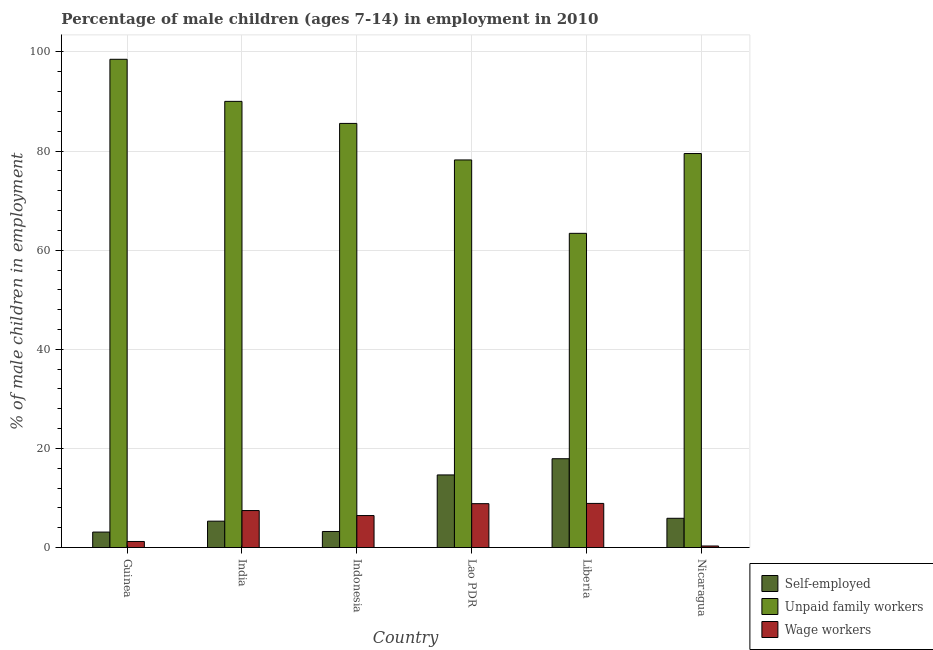How many different coloured bars are there?
Ensure brevity in your answer.  3. How many groups of bars are there?
Provide a short and direct response. 6. Are the number of bars per tick equal to the number of legend labels?
Keep it short and to the point. Yes. Are the number of bars on each tick of the X-axis equal?
Keep it short and to the point. Yes. What is the label of the 1st group of bars from the left?
Provide a short and direct response. Guinea. In how many cases, is the number of bars for a given country not equal to the number of legend labels?
Keep it short and to the point. 0. What is the percentage of self employed children in Liberia?
Provide a short and direct response. 17.92. Across all countries, what is the minimum percentage of children employed as wage workers?
Give a very brief answer. 0.31. In which country was the percentage of self employed children maximum?
Provide a short and direct response. Liberia. In which country was the percentage of children employed as unpaid family workers minimum?
Offer a terse response. Liberia. What is the total percentage of children employed as unpaid family workers in the graph?
Your answer should be very brief. 495.24. What is the difference between the percentage of self employed children in India and that in Liberia?
Provide a succinct answer. -12.6. What is the difference between the percentage of children employed as unpaid family workers in Nicaragua and the percentage of children employed as wage workers in Guinea?
Your answer should be compact. 78.28. What is the average percentage of self employed children per country?
Your answer should be compact. 8.36. What is the difference between the percentage of children employed as unpaid family workers and percentage of self employed children in Guinea?
Provide a succinct answer. 95.4. In how many countries, is the percentage of self employed children greater than 76 %?
Give a very brief answer. 0. What is the ratio of the percentage of self employed children in Guinea to that in Indonesia?
Give a very brief answer. 0.96. Is the percentage of self employed children in Lao PDR less than that in Nicaragua?
Offer a very short reply. No. What is the difference between the highest and the second highest percentage of children employed as wage workers?
Give a very brief answer. 0.05. What is the difference between the highest and the lowest percentage of children employed as unpaid family workers?
Your response must be concise. 35.12. In how many countries, is the percentage of children employed as unpaid family workers greater than the average percentage of children employed as unpaid family workers taken over all countries?
Your answer should be very brief. 3. What does the 3rd bar from the left in Nicaragua represents?
Your answer should be compact. Wage workers. What does the 1st bar from the right in India represents?
Offer a terse response. Wage workers. Are all the bars in the graph horizontal?
Make the answer very short. No. Are the values on the major ticks of Y-axis written in scientific E-notation?
Provide a short and direct response. No. Does the graph contain any zero values?
Provide a succinct answer. No. What is the title of the graph?
Offer a terse response. Percentage of male children (ages 7-14) in employment in 2010. Does "Infant(male)" appear as one of the legend labels in the graph?
Ensure brevity in your answer.  No. What is the label or title of the X-axis?
Offer a very short reply. Country. What is the label or title of the Y-axis?
Make the answer very short. % of male children in employment. What is the % of male children in employment of Self-employed in Guinea?
Provide a succinct answer. 3.12. What is the % of male children in employment in Unpaid family workers in Guinea?
Your response must be concise. 98.52. What is the % of male children in employment of Wage workers in Guinea?
Provide a short and direct response. 1.22. What is the % of male children in employment in Self-employed in India?
Give a very brief answer. 5.32. What is the % of male children in employment of Unpaid family workers in India?
Offer a very short reply. 90.03. What is the % of male children in employment in Wage workers in India?
Provide a short and direct response. 7.46. What is the % of male children in employment of Self-employed in Indonesia?
Your answer should be very brief. 3.24. What is the % of male children in employment of Unpaid family workers in Indonesia?
Ensure brevity in your answer.  85.58. What is the % of male children in employment in Wage workers in Indonesia?
Your answer should be very brief. 6.45. What is the % of male children in employment in Self-employed in Lao PDR?
Ensure brevity in your answer.  14.65. What is the % of male children in employment of Unpaid family workers in Lao PDR?
Ensure brevity in your answer.  78.21. What is the % of male children in employment of Wage workers in Lao PDR?
Ensure brevity in your answer.  8.85. What is the % of male children in employment of Self-employed in Liberia?
Give a very brief answer. 17.92. What is the % of male children in employment of Unpaid family workers in Liberia?
Provide a succinct answer. 63.4. What is the % of male children in employment in Unpaid family workers in Nicaragua?
Your answer should be very brief. 79.5. What is the % of male children in employment of Wage workers in Nicaragua?
Your answer should be compact. 0.31. Across all countries, what is the maximum % of male children in employment of Self-employed?
Your answer should be compact. 17.92. Across all countries, what is the maximum % of male children in employment of Unpaid family workers?
Your answer should be compact. 98.52. Across all countries, what is the minimum % of male children in employment of Self-employed?
Provide a short and direct response. 3.12. Across all countries, what is the minimum % of male children in employment of Unpaid family workers?
Ensure brevity in your answer.  63.4. Across all countries, what is the minimum % of male children in employment in Wage workers?
Offer a terse response. 0.31. What is the total % of male children in employment of Self-employed in the graph?
Ensure brevity in your answer.  50.15. What is the total % of male children in employment of Unpaid family workers in the graph?
Keep it short and to the point. 495.24. What is the total % of male children in employment in Wage workers in the graph?
Give a very brief answer. 33.19. What is the difference between the % of male children in employment of Self-employed in Guinea and that in India?
Your response must be concise. -2.2. What is the difference between the % of male children in employment in Unpaid family workers in Guinea and that in India?
Provide a short and direct response. 8.49. What is the difference between the % of male children in employment of Wage workers in Guinea and that in India?
Ensure brevity in your answer.  -6.24. What is the difference between the % of male children in employment in Self-employed in Guinea and that in Indonesia?
Give a very brief answer. -0.12. What is the difference between the % of male children in employment of Unpaid family workers in Guinea and that in Indonesia?
Keep it short and to the point. 12.94. What is the difference between the % of male children in employment in Wage workers in Guinea and that in Indonesia?
Offer a very short reply. -5.23. What is the difference between the % of male children in employment in Self-employed in Guinea and that in Lao PDR?
Give a very brief answer. -11.53. What is the difference between the % of male children in employment in Unpaid family workers in Guinea and that in Lao PDR?
Make the answer very short. 20.31. What is the difference between the % of male children in employment of Wage workers in Guinea and that in Lao PDR?
Your answer should be very brief. -7.63. What is the difference between the % of male children in employment of Self-employed in Guinea and that in Liberia?
Provide a short and direct response. -14.8. What is the difference between the % of male children in employment of Unpaid family workers in Guinea and that in Liberia?
Make the answer very short. 35.12. What is the difference between the % of male children in employment in Wage workers in Guinea and that in Liberia?
Your answer should be compact. -7.68. What is the difference between the % of male children in employment of Self-employed in Guinea and that in Nicaragua?
Your answer should be very brief. -2.78. What is the difference between the % of male children in employment of Unpaid family workers in Guinea and that in Nicaragua?
Provide a short and direct response. 19.02. What is the difference between the % of male children in employment of Wage workers in Guinea and that in Nicaragua?
Offer a very short reply. 0.91. What is the difference between the % of male children in employment in Self-employed in India and that in Indonesia?
Ensure brevity in your answer.  2.08. What is the difference between the % of male children in employment of Unpaid family workers in India and that in Indonesia?
Ensure brevity in your answer.  4.45. What is the difference between the % of male children in employment in Self-employed in India and that in Lao PDR?
Give a very brief answer. -9.33. What is the difference between the % of male children in employment of Unpaid family workers in India and that in Lao PDR?
Offer a terse response. 11.82. What is the difference between the % of male children in employment of Wage workers in India and that in Lao PDR?
Offer a very short reply. -1.39. What is the difference between the % of male children in employment of Unpaid family workers in India and that in Liberia?
Ensure brevity in your answer.  26.63. What is the difference between the % of male children in employment in Wage workers in India and that in Liberia?
Your response must be concise. -1.44. What is the difference between the % of male children in employment in Self-employed in India and that in Nicaragua?
Your answer should be compact. -0.58. What is the difference between the % of male children in employment of Unpaid family workers in India and that in Nicaragua?
Your response must be concise. 10.53. What is the difference between the % of male children in employment of Wage workers in India and that in Nicaragua?
Offer a terse response. 7.15. What is the difference between the % of male children in employment in Self-employed in Indonesia and that in Lao PDR?
Offer a terse response. -11.41. What is the difference between the % of male children in employment in Unpaid family workers in Indonesia and that in Lao PDR?
Offer a very short reply. 7.37. What is the difference between the % of male children in employment in Self-employed in Indonesia and that in Liberia?
Ensure brevity in your answer.  -14.68. What is the difference between the % of male children in employment of Unpaid family workers in Indonesia and that in Liberia?
Provide a succinct answer. 22.18. What is the difference between the % of male children in employment in Wage workers in Indonesia and that in Liberia?
Keep it short and to the point. -2.45. What is the difference between the % of male children in employment of Self-employed in Indonesia and that in Nicaragua?
Your response must be concise. -2.66. What is the difference between the % of male children in employment in Unpaid family workers in Indonesia and that in Nicaragua?
Give a very brief answer. 6.08. What is the difference between the % of male children in employment in Wage workers in Indonesia and that in Nicaragua?
Keep it short and to the point. 6.14. What is the difference between the % of male children in employment in Self-employed in Lao PDR and that in Liberia?
Your answer should be compact. -3.27. What is the difference between the % of male children in employment of Unpaid family workers in Lao PDR and that in Liberia?
Your answer should be compact. 14.81. What is the difference between the % of male children in employment in Wage workers in Lao PDR and that in Liberia?
Your answer should be very brief. -0.05. What is the difference between the % of male children in employment in Self-employed in Lao PDR and that in Nicaragua?
Make the answer very short. 8.75. What is the difference between the % of male children in employment in Unpaid family workers in Lao PDR and that in Nicaragua?
Provide a short and direct response. -1.29. What is the difference between the % of male children in employment in Wage workers in Lao PDR and that in Nicaragua?
Your answer should be very brief. 8.54. What is the difference between the % of male children in employment in Self-employed in Liberia and that in Nicaragua?
Give a very brief answer. 12.02. What is the difference between the % of male children in employment of Unpaid family workers in Liberia and that in Nicaragua?
Offer a terse response. -16.1. What is the difference between the % of male children in employment of Wage workers in Liberia and that in Nicaragua?
Offer a very short reply. 8.59. What is the difference between the % of male children in employment in Self-employed in Guinea and the % of male children in employment in Unpaid family workers in India?
Provide a short and direct response. -86.91. What is the difference between the % of male children in employment of Self-employed in Guinea and the % of male children in employment of Wage workers in India?
Keep it short and to the point. -4.34. What is the difference between the % of male children in employment of Unpaid family workers in Guinea and the % of male children in employment of Wage workers in India?
Offer a terse response. 91.06. What is the difference between the % of male children in employment in Self-employed in Guinea and the % of male children in employment in Unpaid family workers in Indonesia?
Your response must be concise. -82.46. What is the difference between the % of male children in employment in Self-employed in Guinea and the % of male children in employment in Wage workers in Indonesia?
Offer a very short reply. -3.33. What is the difference between the % of male children in employment in Unpaid family workers in Guinea and the % of male children in employment in Wage workers in Indonesia?
Offer a terse response. 92.07. What is the difference between the % of male children in employment in Self-employed in Guinea and the % of male children in employment in Unpaid family workers in Lao PDR?
Make the answer very short. -75.09. What is the difference between the % of male children in employment of Self-employed in Guinea and the % of male children in employment of Wage workers in Lao PDR?
Your answer should be very brief. -5.73. What is the difference between the % of male children in employment in Unpaid family workers in Guinea and the % of male children in employment in Wage workers in Lao PDR?
Ensure brevity in your answer.  89.67. What is the difference between the % of male children in employment in Self-employed in Guinea and the % of male children in employment in Unpaid family workers in Liberia?
Keep it short and to the point. -60.28. What is the difference between the % of male children in employment of Self-employed in Guinea and the % of male children in employment of Wage workers in Liberia?
Offer a terse response. -5.78. What is the difference between the % of male children in employment in Unpaid family workers in Guinea and the % of male children in employment in Wage workers in Liberia?
Make the answer very short. 89.62. What is the difference between the % of male children in employment in Self-employed in Guinea and the % of male children in employment in Unpaid family workers in Nicaragua?
Your answer should be compact. -76.38. What is the difference between the % of male children in employment in Self-employed in Guinea and the % of male children in employment in Wage workers in Nicaragua?
Your answer should be compact. 2.81. What is the difference between the % of male children in employment of Unpaid family workers in Guinea and the % of male children in employment of Wage workers in Nicaragua?
Your answer should be compact. 98.21. What is the difference between the % of male children in employment of Self-employed in India and the % of male children in employment of Unpaid family workers in Indonesia?
Offer a terse response. -80.26. What is the difference between the % of male children in employment of Self-employed in India and the % of male children in employment of Wage workers in Indonesia?
Make the answer very short. -1.13. What is the difference between the % of male children in employment of Unpaid family workers in India and the % of male children in employment of Wage workers in Indonesia?
Make the answer very short. 83.58. What is the difference between the % of male children in employment of Self-employed in India and the % of male children in employment of Unpaid family workers in Lao PDR?
Keep it short and to the point. -72.89. What is the difference between the % of male children in employment of Self-employed in India and the % of male children in employment of Wage workers in Lao PDR?
Your answer should be very brief. -3.53. What is the difference between the % of male children in employment of Unpaid family workers in India and the % of male children in employment of Wage workers in Lao PDR?
Provide a short and direct response. 81.18. What is the difference between the % of male children in employment of Self-employed in India and the % of male children in employment of Unpaid family workers in Liberia?
Offer a terse response. -58.08. What is the difference between the % of male children in employment of Self-employed in India and the % of male children in employment of Wage workers in Liberia?
Ensure brevity in your answer.  -3.58. What is the difference between the % of male children in employment of Unpaid family workers in India and the % of male children in employment of Wage workers in Liberia?
Provide a succinct answer. 81.13. What is the difference between the % of male children in employment of Self-employed in India and the % of male children in employment of Unpaid family workers in Nicaragua?
Ensure brevity in your answer.  -74.18. What is the difference between the % of male children in employment of Self-employed in India and the % of male children in employment of Wage workers in Nicaragua?
Offer a very short reply. 5.01. What is the difference between the % of male children in employment in Unpaid family workers in India and the % of male children in employment in Wage workers in Nicaragua?
Provide a short and direct response. 89.72. What is the difference between the % of male children in employment of Self-employed in Indonesia and the % of male children in employment of Unpaid family workers in Lao PDR?
Your answer should be compact. -74.97. What is the difference between the % of male children in employment of Self-employed in Indonesia and the % of male children in employment of Wage workers in Lao PDR?
Provide a short and direct response. -5.61. What is the difference between the % of male children in employment of Unpaid family workers in Indonesia and the % of male children in employment of Wage workers in Lao PDR?
Give a very brief answer. 76.73. What is the difference between the % of male children in employment in Self-employed in Indonesia and the % of male children in employment in Unpaid family workers in Liberia?
Make the answer very short. -60.16. What is the difference between the % of male children in employment in Self-employed in Indonesia and the % of male children in employment in Wage workers in Liberia?
Your answer should be very brief. -5.66. What is the difference between the % of male children in employment in Unpaid family workers in Indonesia and the % of male children in employment in Wage workers in Liberia?
Your answer should be compact. 76.68. What is the difference between the % of male children in employment of Self-employed in Indonesia and the % of male children in employment of Unpaid family workers in Nicaragua?
Your answer should be compact. -76.26. What is the difference between the % of male children in employment of Self-employed in Indonesia and the % of male children in employment of Wage workers in Nicaragua?
Give a very brief answer. 2.93. What is the difference between the % of male children in employment in Unpaid family workers in Indonesia and the % of male children in employment in Wage workers in Nicaragua?
Offer a terse response. 85.27. What is the difference between the % of male children in employment in Self-employed in Lao PDR and the % of male children in employment in Unpaid family workers in Liberia?
Your response must be concise. -48.75. What is the difference between the % of male children in employment of Self-employed in Lao PDR and the % of male children in employment of Wage workers in Liberia?
Ensure brevity in your answer.  5.75. What is the difference between the % of male children in employment in Unpaid family workers in Lao PDR and the % of male children in employment in Wage workers in Liberia?
Ensure brevity in your answer.  69.31. What is the difference between the % of male children in employment in Self-employed in Lao PDR and the % of male children in employment in Unpaid family workers in Nicaragua?
Offer a terse response. -64.85. What is the difference between the % of male children in employment of Self-employed in Lao PDR and the % of male children in employment of Wage workers in Nicaragua?
Give a very brief answer. 14.34. What is the difference between the % of male children in employment in Unpaid family workers in Lao PDR and the % of male children in employment in Wage workers in Nicaragua?
Provide a succinct answer. 77.9. What is the difference between the % of male children in employment of Self-employed in Liberia and the % of male children in employment of Unpaid family workers in Nicaragua?
Your answer should be very brief. -61.58. What is the difference between the % of male children in employment of Self-employed in Liberia and the % of male children in employment of Wage workers in Nicaragua?
Give a very brief answer. 17.61. What is the difference between the % of male children in employment in Unpaid family workers in Liberia and the % of male children in employment in Wage workers in Nicaragua?
Your response must be concise. 63.09. What is the average % of male children in employment of Self-employed per country?
Provide a succinct answer. 8.36. What is the average % of male children in employment in Unpaid family workers per country?
Your answer should be compact. 82.54. What is the average % of male children in employment of Wage workers per country?
Make the answer very short. 5.53. What is the difference between the % of male children in employment in Self-employed and % of male children in employment in Unpaid family workers in Guinea?
Give a very brief answer. -95.4. What is the difference between the % of male children in employment in Unpaid family workers and % of male children in employment in Wage workers in Guinea?
Your answer should be very brief. 97.3. What is the difference between the % of male children in employment in Self-employed and % of male children in employment in Unpaid family workers in India?
Offer a very short reply. -84.71. What is the difference between the % of male children in employment of Self-employed and % of male children in employment of Wage workers in India?
Keep it short and to the point. -2.14. What is the difference between the % of male children in employment in Unpaid family workers and % of male children in employment in Wage workers in India?
Offer a terse response. 82.57. What is the difference between the % of male children in employment of Self-employed and % of male children in employment of Unpaid family workers in Indonesia?
Make the answer very short. -82.34. What is the difference between the % of male children in employment in Self-employed and % of male children in employment in Wage workers in Indonesia?
Give a very brief answer. -3.21. What is the difference between the % of male children in employment of Unpaid family workers and % of male children in employment of Wage workers in Indonesia?
Offer a very short reply. 79.13. What is the difference between the % of male children in employment of Self-employed and % of male children in employment of Unpaid family workers in Lao PDR?
Offer a very short reply. -63.56. What is the difference between the % of male children in employment in Unpaid family workers and % of male children in employment in Wage workers in Lao PDR?
Give a very brief answer. 69.36. What is the difference between the % of male children in employment in Self-employed and % of male children in employment in Unpaid family workers in Liberia?
Provide a succinct answer. -45.48. What is the difference between the % of male children in employment in Self-employed and % of male children in employment in Wage workers in Liberia?
Provide a succinct answer. 9.02. What is the difference between the % of male children in employment of Unpaid family workers and % of male children in employment of Wage workers in Liberia?
Your response must be concise. 54.5. What is the difference between the % of male children in employment in Self-employed and % of male children in employment in Unpaid family workers in Nicaragua?
Your answer should be very brief. -73.6. What is the difference between the % of male children in employment in Self-employed and % of male children in employment in Wage workers in Nicaragua?
Keep it short and to the point. 5.59. What is the difference between the % of male children in employment in Unpaid family workers and % of male children in employment in Wage workers in Nicaragua?
Ensure brevity in your answer.  79.19. What is the ratio of the % of male children in employment in Self-employed in Guinea to that in India?
Your answer should be very brief. 0.59. What is the ratio of the % of male children in employment of Unpaid family workers in Guinea to that in India?
Ensure brevity in your answer.  1.09. What is the ratio of the % of male children in employment of Wage workers in Guinea to that in India?
Your answer should be compact. 0.16. What is the ratio of the % of male children in employment in Unpaid family workers in Guinea to that in Indonesia?
Make the answer very short. 1.15. What is the ratio of the % of male children in employment of Wage workers in Guinea to that in Indonesia?
Make the answer very short. 0.19. What is the ratio of the % of male children in employment of Self-employed in Guinea to that in Lao PDR?
Make the answer very short. 0.21. What is the ratio of the % of male children in employment of Unpaid family workers in Guinea to that in Lao PDR?
Keep it short and to the point. 1.26. What is the ratio of the % of male children in employment of Wage workers in Guinea to that in Lao PDR?
Offer a very short reply. 0.14. What is the ratio of the % of male children in employment in Self-employed in Guinea to that in Liberia?
Provide a short and direct response. 0.17. What is the ratio of the % of male children in employment of Unpaid family workers in Guinea to that in Liberia?
Offer a very short reply. 1.55. What is the ratio of the % of male children in employment of Wage workers in Guinea to that in Liberia?
Your response must be concise. 0.14. What is the ratio of the % of male children in employment in Self-employed in Guinea to that in Nicaragua?
Provide a succinct answer. 0.53. What is the ratio of the % of male children in employment of Unpaid family workers in Guinea to that in Nicaragua?
Offer a terse response. 1.24. What is the ratio of the % of male children in employment of Wage workers in Guinea to that in Nicaragua?
Make the answer very short. 3.94. What is the ratio of the % of male children in employment in Self-employed in India to that in Indonesia?
Make the answer very short. 1.64. What is the ratio of the % of male children in employment of Unpaid family workers in India to that in Indonesia?
Your answer should be very brief. 1.05. What is the ratio of the % of male children in employment of Wage workers in India to that in Indonesia?
Give a very brief answer. 1.16. What is the ratio of the % of male children in employment of Self-employed in India to that in Lao PDR?
Make the answer very short. 0.36. What is the ratio of the % of male children in employment of Unpaid family workers in India to that in Lao PDR?
Provide a succinct answer. 1.15. What is the ratio of the % of male children in employment in Wage workers in India to that in Lao PDR?
Offer a terse response. 0.84. What is the ratio of the % of male children in employment in Self-employed in India to that in Liberia?
Provide a succinct answer. 0.3. What is the ratio of the % of male children in employment in Unpaid family workers in India to that in Liberia?
Provide a succinct answer. 1.42. What is the ratio of the % of male children in employment of Wage workers in India to that in Liberia?
Keep it short and to the point. 0.84. What is the ratio of the % of male children in employment in Self-employed in India to that in Nicaragua?
Ensure brevity in your answer.  0.9. What is the ratio of the % of male children in employment in Unpaid family workers in India to that in Nicaragua?
Your answer should be very brief. 1.13. What is the ratio of the % of male children in employment of Wage workers in India to that in Nicaragua?
Your response must be concise. 24.06. What is the ratio of the % of male children in employment in Self-employed in Indonesia to that in Lao PDR?
Offer a terse response. 0.22. What is the ratio of the % of male children in employment of Unpaid family workers in Indonesia to that in Lao PDR?
Offer a very short reply. 1.09. What is the ratio of the % of male children in employment in Wage workers in Indonesia to that in Lao PDR?
Offer a terse response. 0.73. What is the ratio of the % of male children in employment of Self-employed in Indonesia to that in Liberia?
Your answer should be very brief. 0.18. What is the ratio of the % of male children in employment in Unpaid family workers in Indonesia to that in Liberia?
Offer a terse response. 1.35. What is the ratio of the % of male children in employment in Wage workers in Indonesia to that in Liberia?
Make the answer very short. 0.72. What is the ratio of the % of male children in employment in Self-employed in Indonesia to that in Nicaragua?
Ensure brevity in your answer.  0.55. What is the ratio of the % of male children in employment of Unpaid family workers in Indonesia to that in Nicaragua?
Offer a terse response. 1.08. What is the ratio of the % of male children in employment of Wage workers in Indonesia to that in Nicaragua?
Your answer should be compact. 20.81. What is the ratio of the % of male children in employment in Self-employed in Lao PDR to that in Liberia?
Your response must be concise. 0.82. What is the ratio of the % of male children in employment of Unpaid family workers in Lao PDR to that in Liberia?
Your response must be concise. 1.23. What is the ratio of the % of male children in employment of Wage workers in Lao PDR to that in Liberia?
Give a very brief answer. 0.99. What is the ratio of the % of male children in employment of Self-employed in Lao PDR to that in Nicaragua?
Offer a very short reply. 2.48. What is the ratio of the % of male children in employment of Unpaid family workers in Lao PDR to that in Nicaragua?
Provide a succinct answer. 0.98. What is the ratio of the % of male children in employment in Wage workers in Lao PDR to that in Nicaragua?
Keep it short and to the point. 28.55. What is the ratio of the % of male children in employment in Self-employed in Liberia to that in Nicaragua?
Ensure brevity in your answer.  3.04. What is the ratio of the % of male children in employment in Unpaid family workers in Liberia to that in Nicaragua?
Keep it short and to the point. 0.8. What is the ratio of the % of male children in employment in Wage workers in Liberia to that in Nicaragua?
Your response must be concise. 28.71. What is the difference between the highest and the second highest % of male children in employment in Self-employed?
Give a very brief answer. 3.27. What is the difference between the highest and the second highest % of male children in employment in Unpaid family workers?
Offer a terse response. 8.49. What is the difference between the highest and the second highest % of male children in employment in Wage workers?
Your answer should be very brief. 0.05. What is the difference between the highest and the lowest % of male children in employment in Self-employed?
Offer a terse response. 14.8. What is the difference between the highest and the lowest % of male children in employment of Unpaid family workers?
Ensure brevity in your answer.  35.12. What is the difference between the highest and the lowest % of male children in employment in Wage workers?
Your answer should be compact. 8.59. 